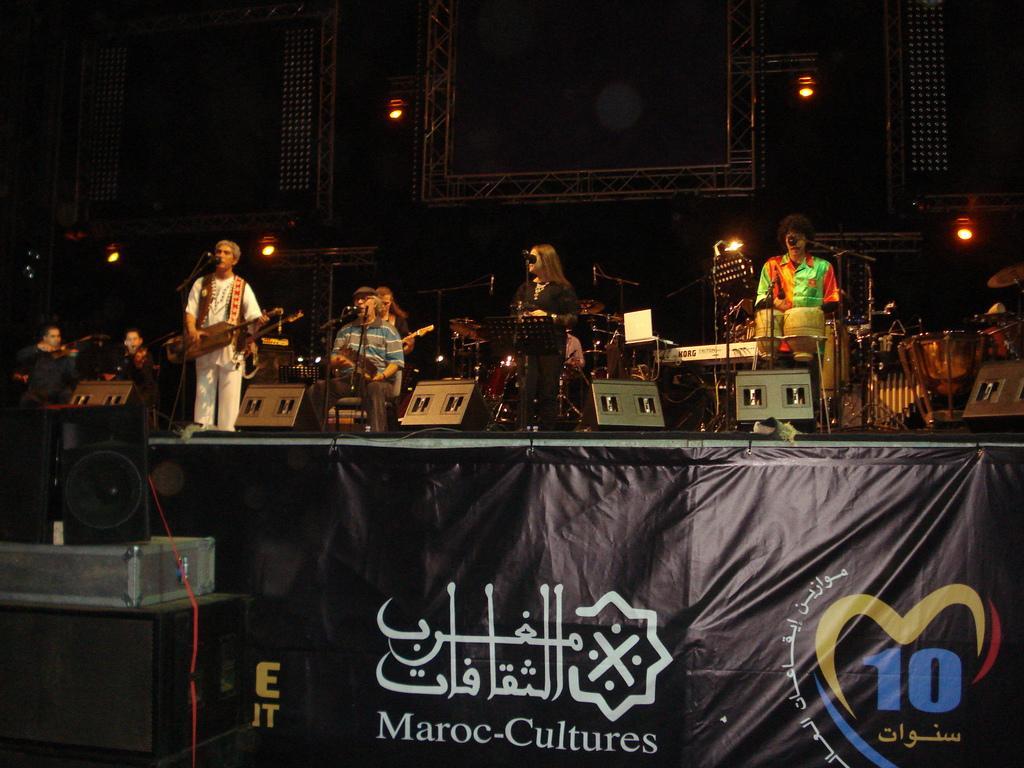How would you summarize this image in a sentence or two? This is a stage. In the front there is a banner. In the left side there is a speaker kept on the table. A person wearing a white dress is holding a musical instrument and singing. there many people in the stage are singing and playing musical instruments. There are drums in the right side. In the background there are lights and stands. Also there are speakers in the front. 